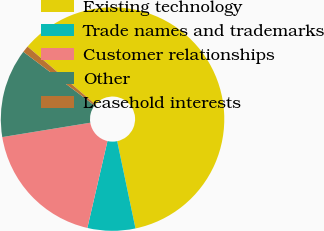Convert chart to OTSL. <chart><loc_0><loc_0><loc_500><loc_500><pie_chart><fcel>Existing technology<fcel>Trade names and trademarks<fcel>Customer relationships<fcel>Other<fcel>Leasehold interests<nl><fcel>60.47%<fcel>6.91%<fcel>18.81%<fcel>12.86%<fcel>0.96%<nl></chart> 